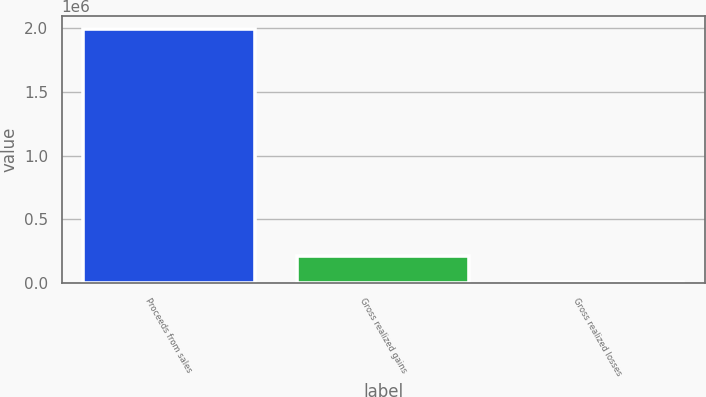Convert chart to OTSL. <chart><loc_0><loc_0><loc_500><loc_500><bar_chart><fcel>Proceeds from sales<fcel>Gross realized gains<fcel>Gross realized losses<nl><fcel>1.99537e+06<fcel>209150<fcel>10681<nl></chart> 